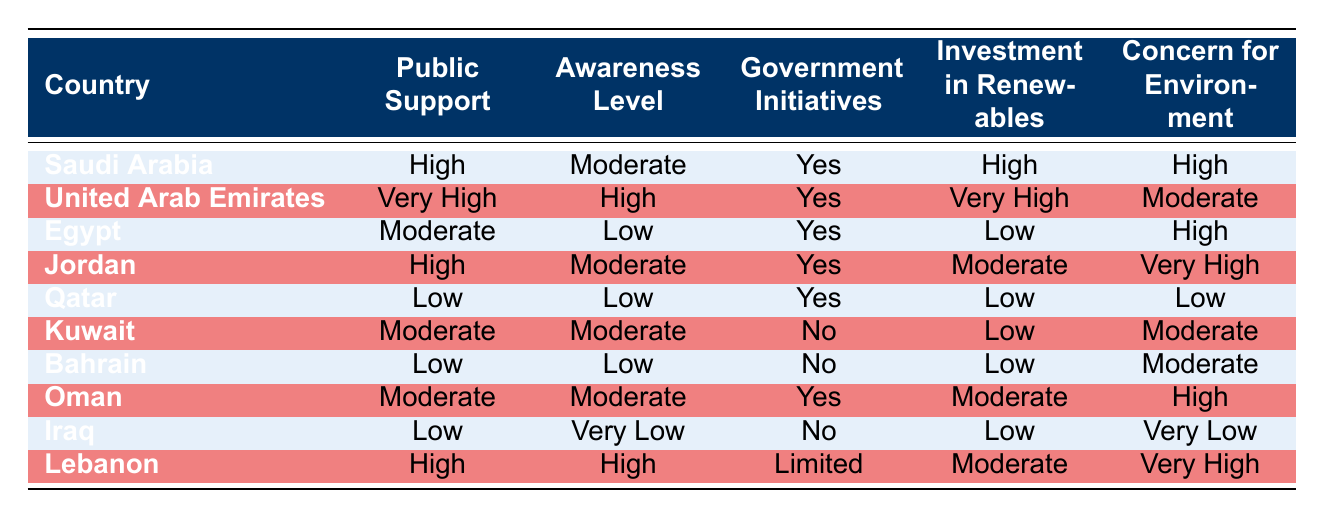What is the public support level for Saudi Arabia regarding renewable energy initiatives? The table clearly lists Saudi Arabia under the "Public Support" column, which shows "High" for public support related to renewable energy initiatives.
Answer: High Which country has the highest public support for renewable energy initiatives? By comparing the values in the "Public Support" column, the United Arab Emirates shows the highest level with "Very High".
Answer: Very High Do all countries with high public support also have high investment in renewables? Looking at the "Public Support" and "Investment in Renewables" columns, countries like Saudi Arabia and Jordan have high support but not necessarily corresponding high investments (Jordan has Moderate). Therefore, the statement is not true.
Answer: No How many countries have moderate public support for renewable energy? The "Public Support" column indicates that Egypt, Kuwait, Oman all show "Moderate" support; thus, there are three such countries.
Answer: 3 Which country has the lowest level of awareness and what is its public support level? The "Awareness Level" shows that Iraq has the lowest level with "Very Low", while the "Public Support" for Iraq is also "Low".
Answer: Low Among the countries with government initiatives, which one has the lowest investment in renewables? By filtering the rows where "Government Initiatives" is "Yes", we see that Egypt has the lowest investment in renewables listed as "Low".
Answer: Egypt If we consider the environmental concern levels, what is the average level of concern for the countries with the highest public support? The highest public support countries are Saudi Arabia, United Arab Emirates, Jordan, and Lebanon. Their environmental concerns are High, Moderate, Very High, and Very High, respectively. Converting these labels into numerical values (High=3, Moderate=2, Very High=4) gives us an average of (3+3+4+4)/4 = 3.5, which corresponds to a level slightly above "High".
Answer: 3.5 What percentage of countries have limited or no government initiatives? In the table, we can see that Kuwait and Bahrain have no government initiatives, and Lebanon has limited initiatives. That amounts to 3 out of 10 countries. To calculate the percentage: (3/10) * 100 = 30%.
Answer: 30% Which country shows a combination of low public support and very low awareness, and what is its investment in renewables? The table shows that Iraq demonstrates low public support at "Low" and awareness at "Very Low", and its investment in renewables is also rated as "Low".
Answer: Low 